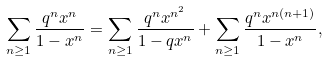Convert formula to latex. <formula><loc_0><loc_0><loc_500><loc_500>\sum _ { n \geq 1 } { \frac { q ^ { n } x ^ { n } } { 1 - x ^ { n } } } = \sum _ { n \geq 1 } { \frac { q ^ { n } x ^ { n ^ { 2 } } } { 1 - q x ^ { n } } } + \sum _ { n \geq 1 } { \frac { q ^ { n } x ^ { n ( n + 1 ) } } { 1 - x ^ { n } } } ,</formula> 